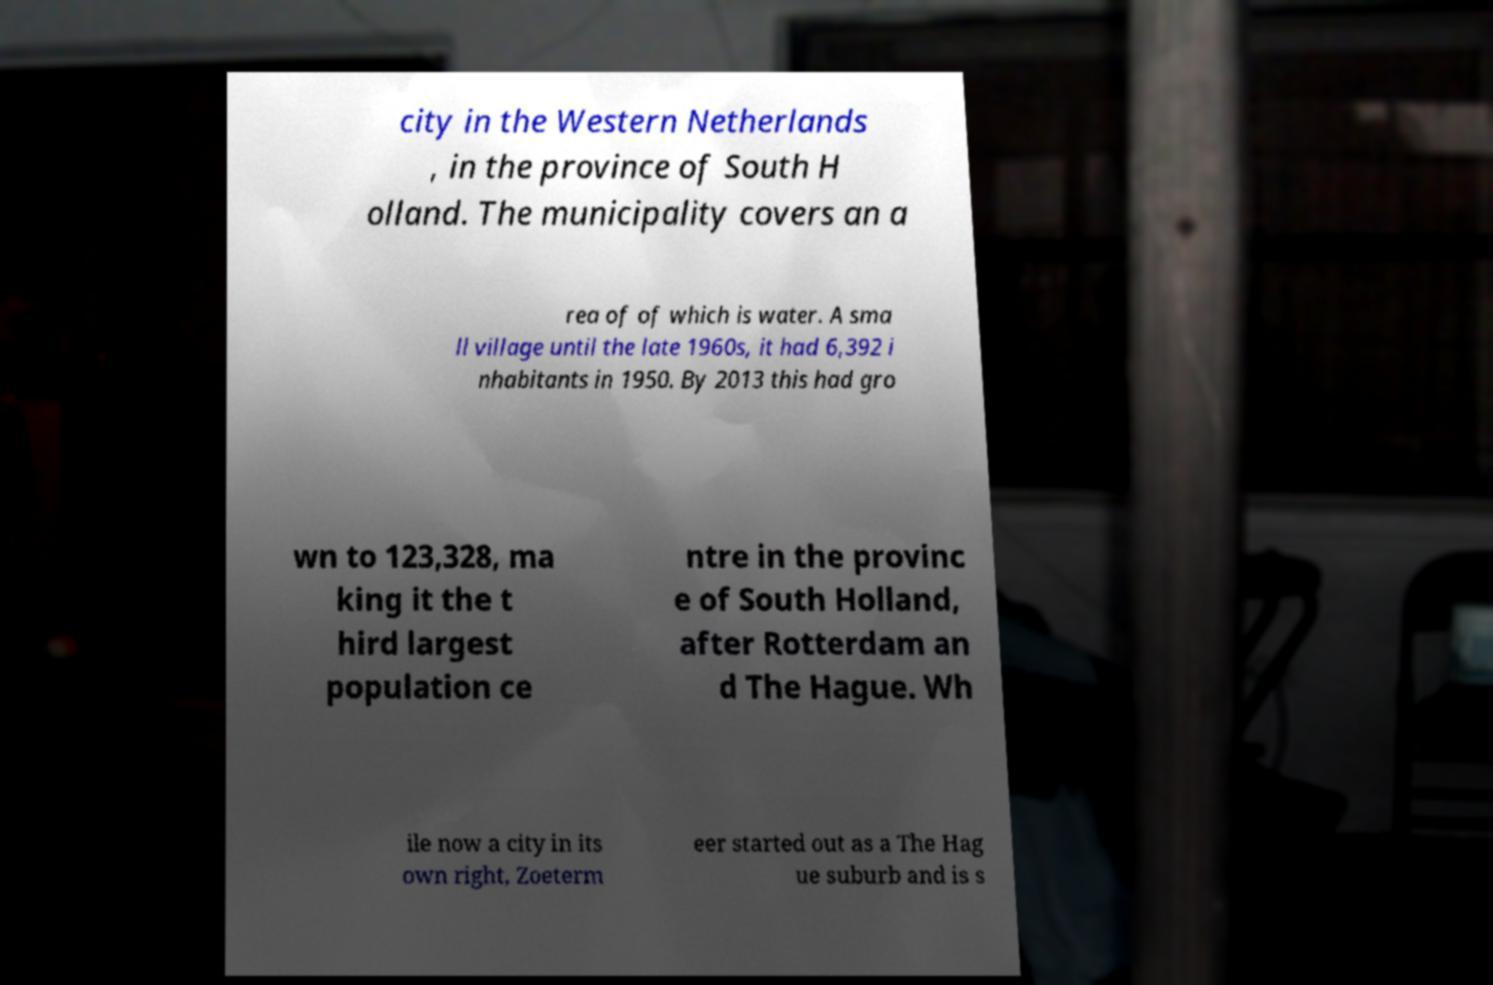There's text embedded in this image that I need extracted. Can you transcribe it verbatim? city in the Western Netherlands , in the province of South H olland. The municipality covers an a rea of of which is water. A sma ll village until the late 1960s, it had 6,392 i nhabitants in 1950. By 2013 this had gro wn to 123,328, ma king it the t hird largest population ce ntre in the provinc e of South Holland, after Rotterdam an d The Hague. Wh ile now a city in its own right, Zoeterm eer started out as a The Hag ue suburb and is s 